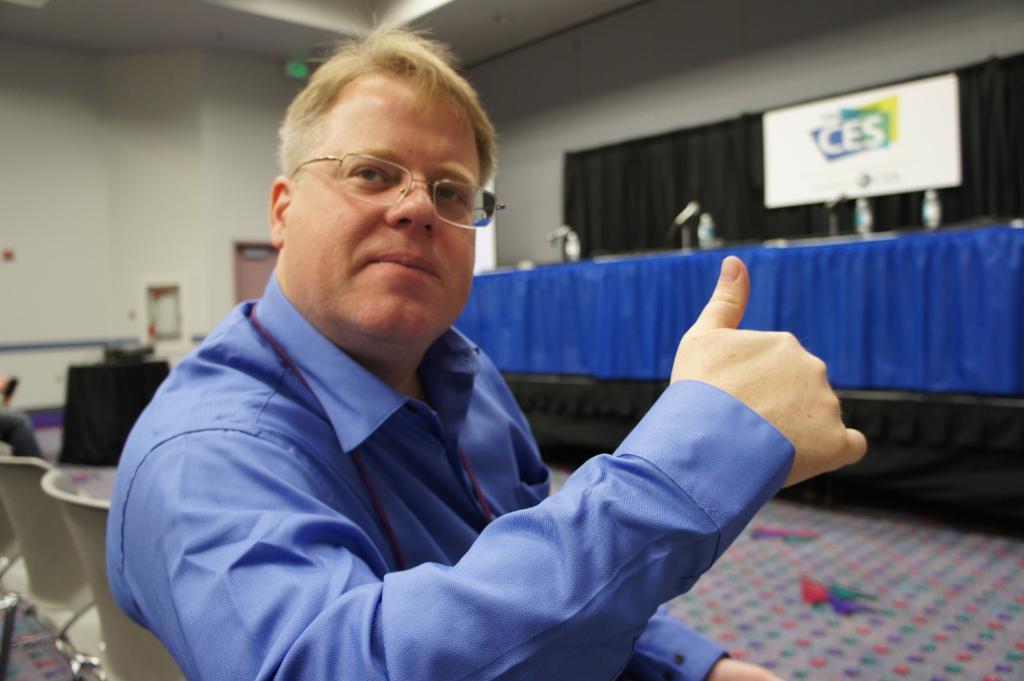Please provide a concise description of this image. This image consists of a man is wearing a blue shirt is sitting in a chair. To the right, there is a dais on which a table is covered with a blue cloth. At the bottom, there is a floor. 